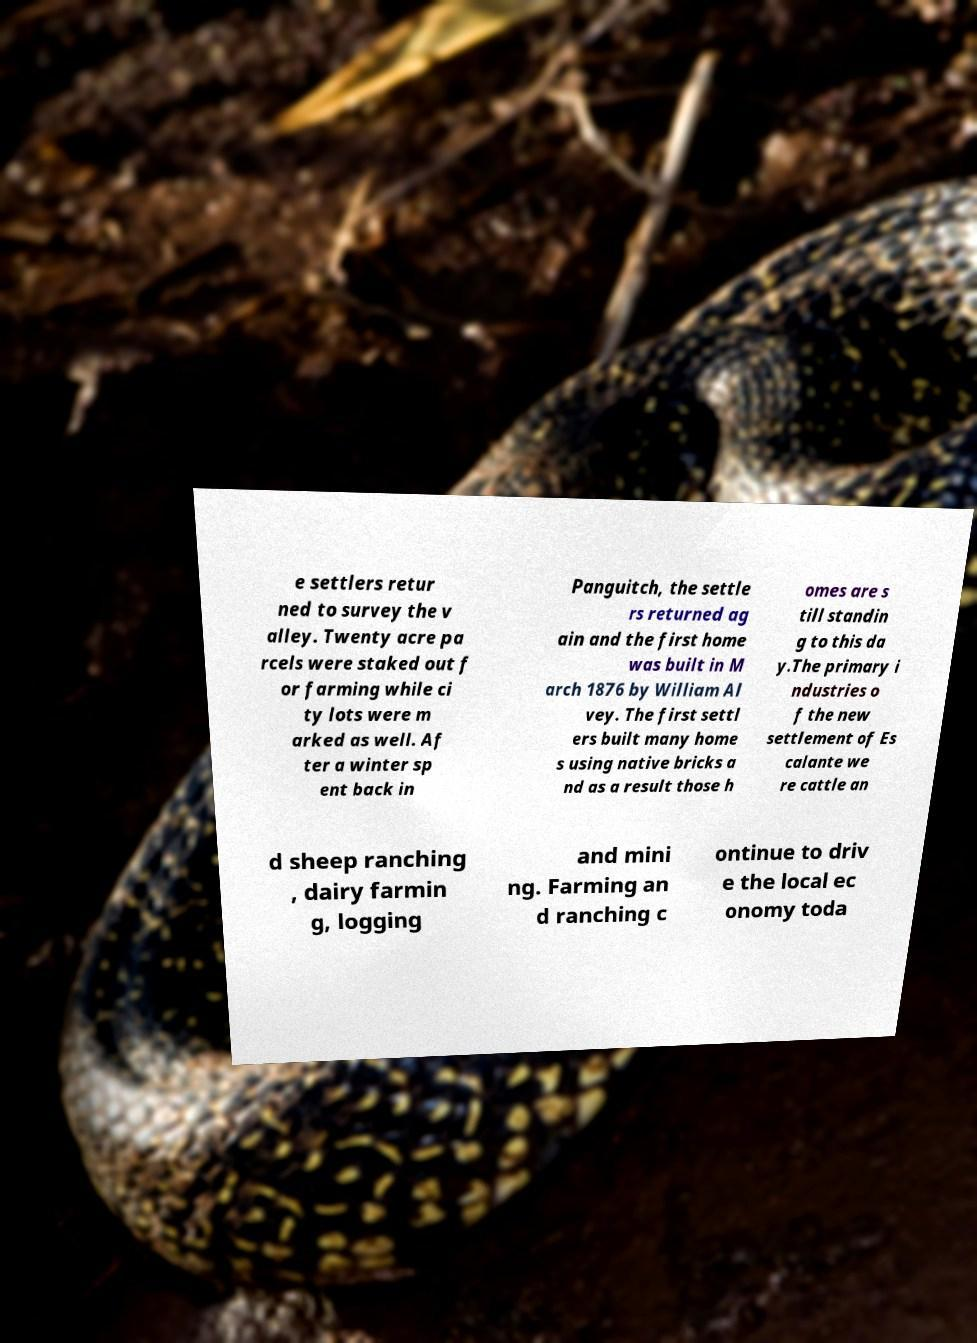Could you assist in decoding the text presented in this image and type it out clearly? e settlers retur ned to survey the v alley. Twenty acre pa rcels were staked out f or farming while ci ty lots were m arked as well. Af ter a winter sp ent back in Panguitch, the settle rs returned ag ain and the first home was built in M arch 1876 by William Al vey. The first settl ers built many home s using native bricks a nd as a result those h omes are s till standin g to this da y.The primary i ndustries o f the new settlement of Es calante we re cattle an d sheep ranching , dairy farmin g, logging and mini ng. Farming an d ranching c ontinue to driv e the local ec onomy toda 